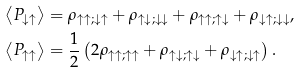<formula> <loc_0><loc_0><loc_500><loc_500>\left \langle P _ { \downarrow \uparrow } \right \rangle & = \rho _ { \uparrow \uparrow ; \downarrow \uparrow } + \rho _ { \uparrow \downarrow ; \downarrow \downarrow } + \rho _ { \uparrow \uparrow ; \uparrow \downarrow } + \rho _ { \downarrow \uparrow ; \downarrow \downarrow } , \\ \left \langle P _ { \uparrow \uparrow } \right \rangle & = \frac { 1 } { 2 } \left ( 2 \rho _ { \uparrow \uparrow ; \uparrow \uparrow } + \rho _ { \uparrow \downarrow ; \uparrow \downarrow } + \rho _ { \downarrow \uparrow ; \downarrow \uparrow } \right ) .</formula> 